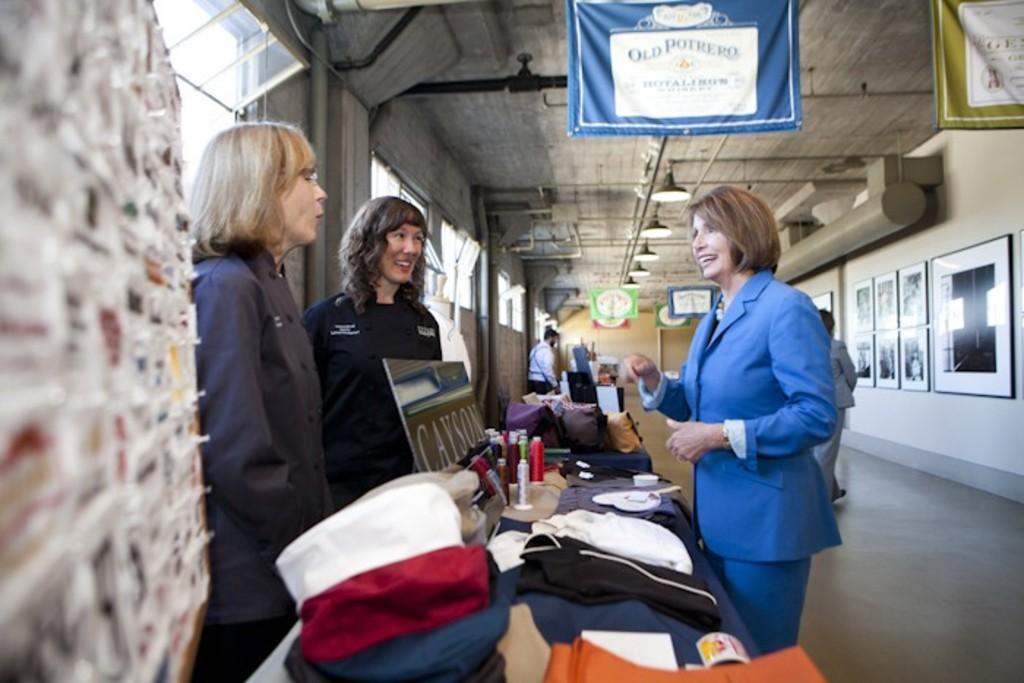Describe this image in one or two sentences. In this image there are clothes, name board and spray bottles on the table , there are group of people standing , clothes tied to the iron rods, lights, windows, frames attached to the wall. 